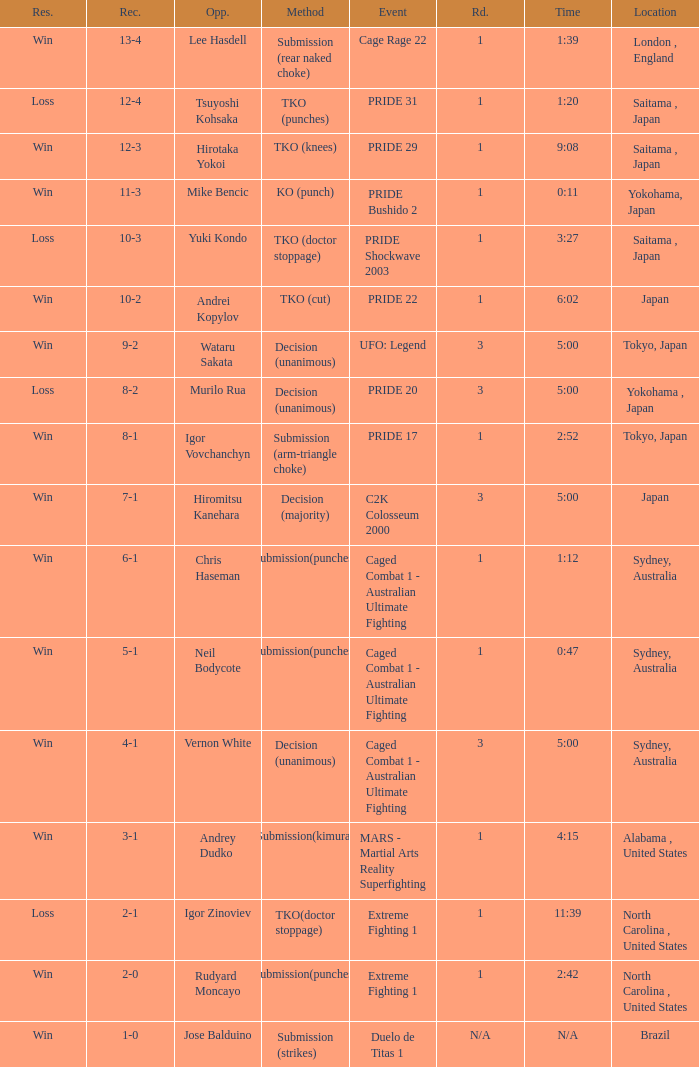Which Record has the Res of win with the Event of extreme fighting 1? 2-0. 